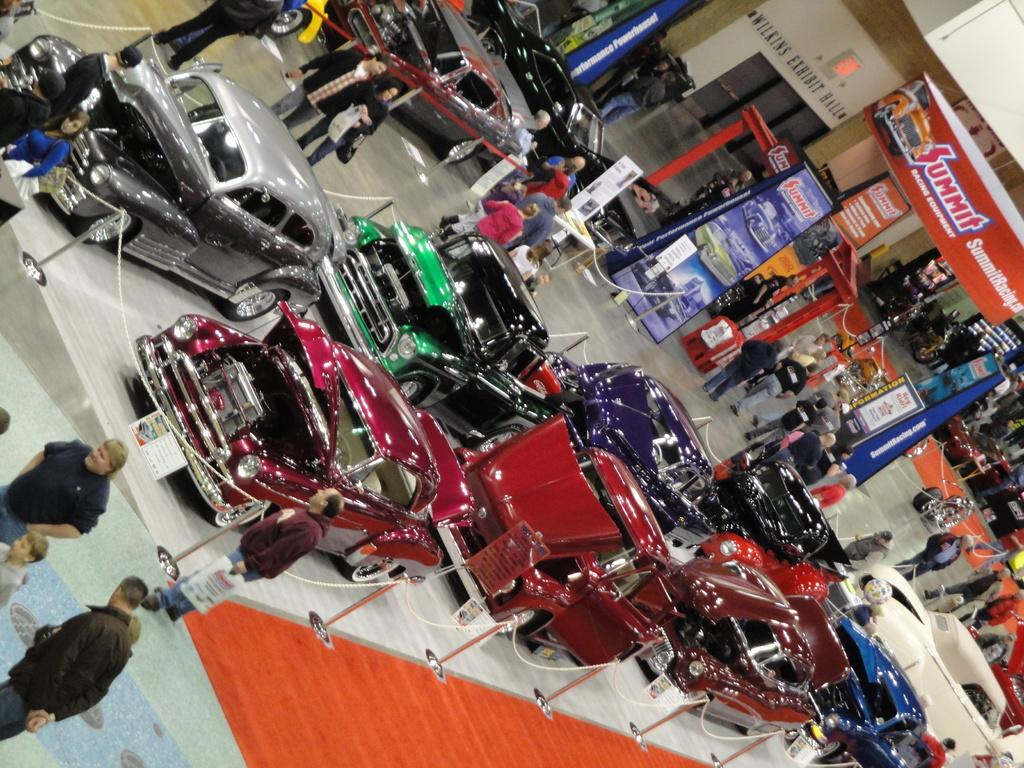What is located in the middle of the image? There are cars in the middle of the image. How many cars are there, and what are their colors? There are multiple cars, and they are of different colors. What are the people in the image doing? There are people walking in the image. What else can be seen in the image besides the cars and people? There are banners and stands in the image. Can you tell me where the toothbrush is located in the image? There is no toothbrush present in the image. What type of monkey can be seen interacting with the cars in the image? There is no monkey present in the image; it features cars, people, banners, and stands. 